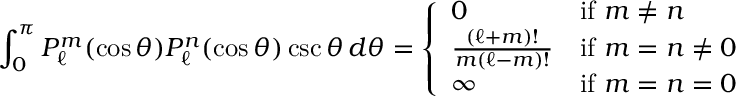Convert formula to latex. <formula><loc_0><loc_0><loc_500><loc_500>\int _ { 0 } ^ { \pi } P _ { \ell } ^ { m } ( \cos \theta ) P _ { \ell } ^ { n } ( \cos \theta ) \csc \theta \, d \theta = { \left \{ \begin{array} { l l } { 0 } & { { i f } m \neq n } \\ { { \frac { ( \ell + m ) ! } { m ( \ell - m ) ! } } } & { { i f } m = n \neq 0 } \\ { \infty } & { { i f } m = n = 0 } \end{array} }</formula> 